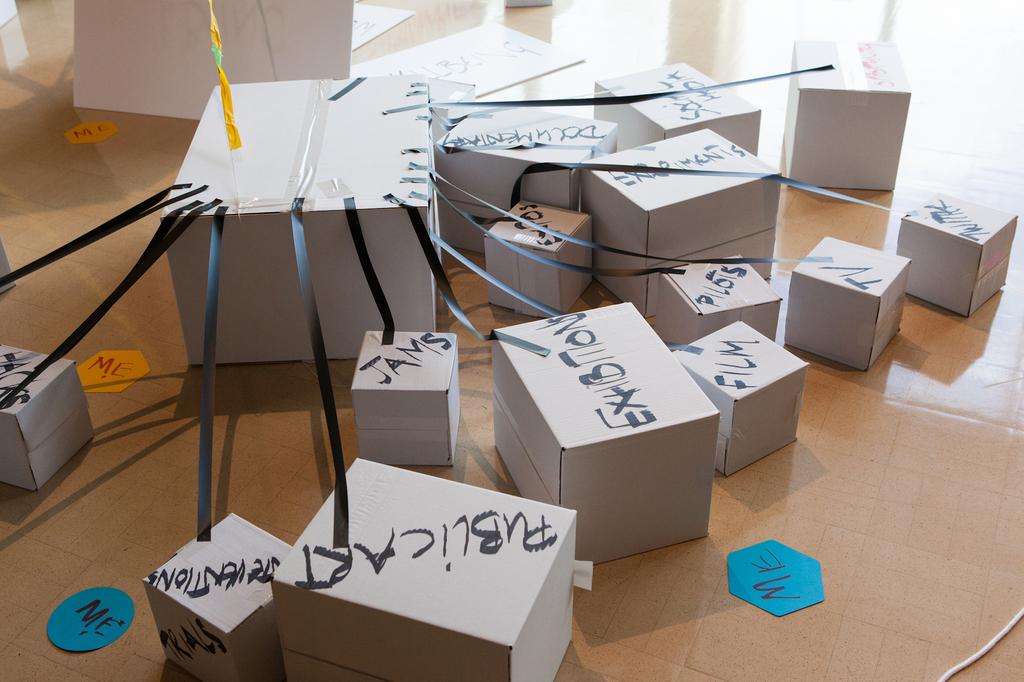What is one of the labels on the box?
Give a very brief answer. Jams. 